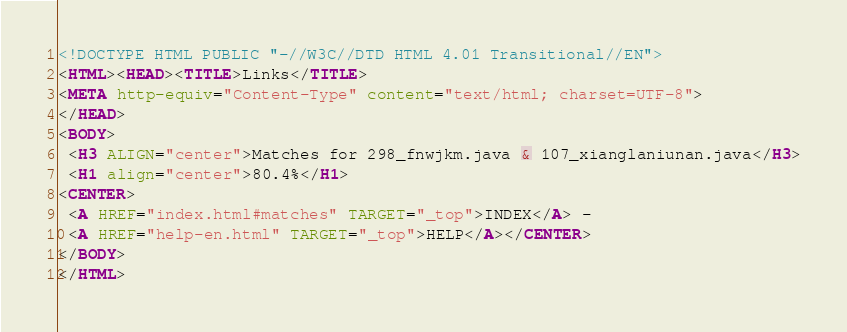<code> <loc_0><loc_0><loc_500><loc_500><_HTML_><!DOCTYPE HTML PUBLIC "-//W3C//DTD HTML 4.01 Transitional//EN">
<HTML><HEAD><TITLE>Links</TITLE>
<META http-equiv="Content-Type" content="text/html; charset=UTF-8">
</HEAD>
<BODY>
 <H3 ALIGN="center">Matches for 298_fnwjkm.java & 107_xianglaniunan.java</H3>
 <H1 align="center">80.4%</H1>
<CENTER>
 <A HREF="index.html#matches" TARGET="_top">INDEX</A> - 
 <A HREF="help-en.html" TARGET="_top">HELP</A></CENTER>
</BODY>
</HTML>
</code> 